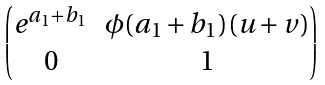Convert formula to latex. <formula><loc_0><loc_0><loc_500><loc_500>\begin{pmatrix} e ^ { a _ { 1 } + b _ { 1 } } & \phi ( a _ { 1 } + b _ { 1 } ) ( u + v ) \\ 0 & 1 \end{pmatrix}</formula> 